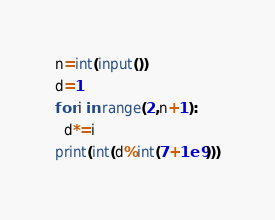Convert code to text. <code><loc_0><loc_0><loc_500><loc_500><_Python_>n=int(input())
d=1
for i in range(2,n+1):
  d*=i
print(int(d%int(7+1e9)))</code> 